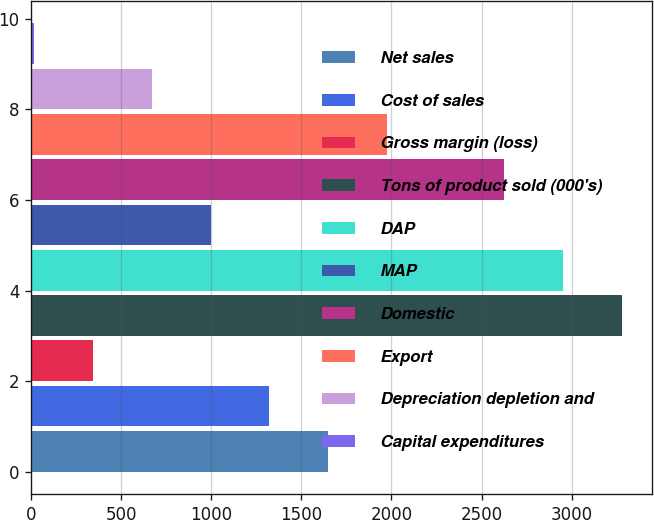Convert chart to OTSL. <chart><loc_0><loc_0><loc_500><loc_500><bar_chart><fcel>Net sales<fcel>Cost of sales<fcel>Gross margin (loss)<fcel>Tons of product sold (000's)<fcel>DAP<fcel>MAP<fcel>Domestic<fcel>Export<fcel>Depreciation depletion and<fcel>Capital expenditures<nl><fcel>1648.1<fcel>1321.72<fcel>342.58<fcel>3280<fcel>2953.62<fcel>995.34<fcel>2627.24<fcel>1974.48<fcel>668.96<fcel>16.2<nl></chart> 